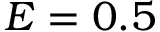Convert formula to latex. <formula><loc_0><loc_0><loc_500><loc_500>E = 0 . 5</formula> 